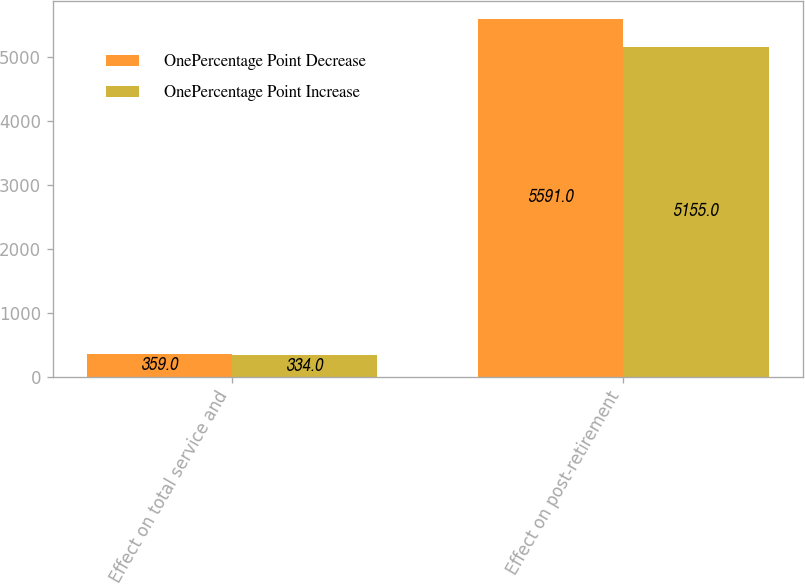Convert chart to OTSL. <chart><loc_0><loc_0><loc_500><loc_500><stacked_bar_chart><ecel><fcel>Effect on total service and<fcel>Effect on post-retirement<nl><fcel>OnePercentage Point Decrease<fcel>359<fcel>5591<nl><fcel>OnePercentage Point Increase<fcel>334<fcel>5155<nl></chart> 